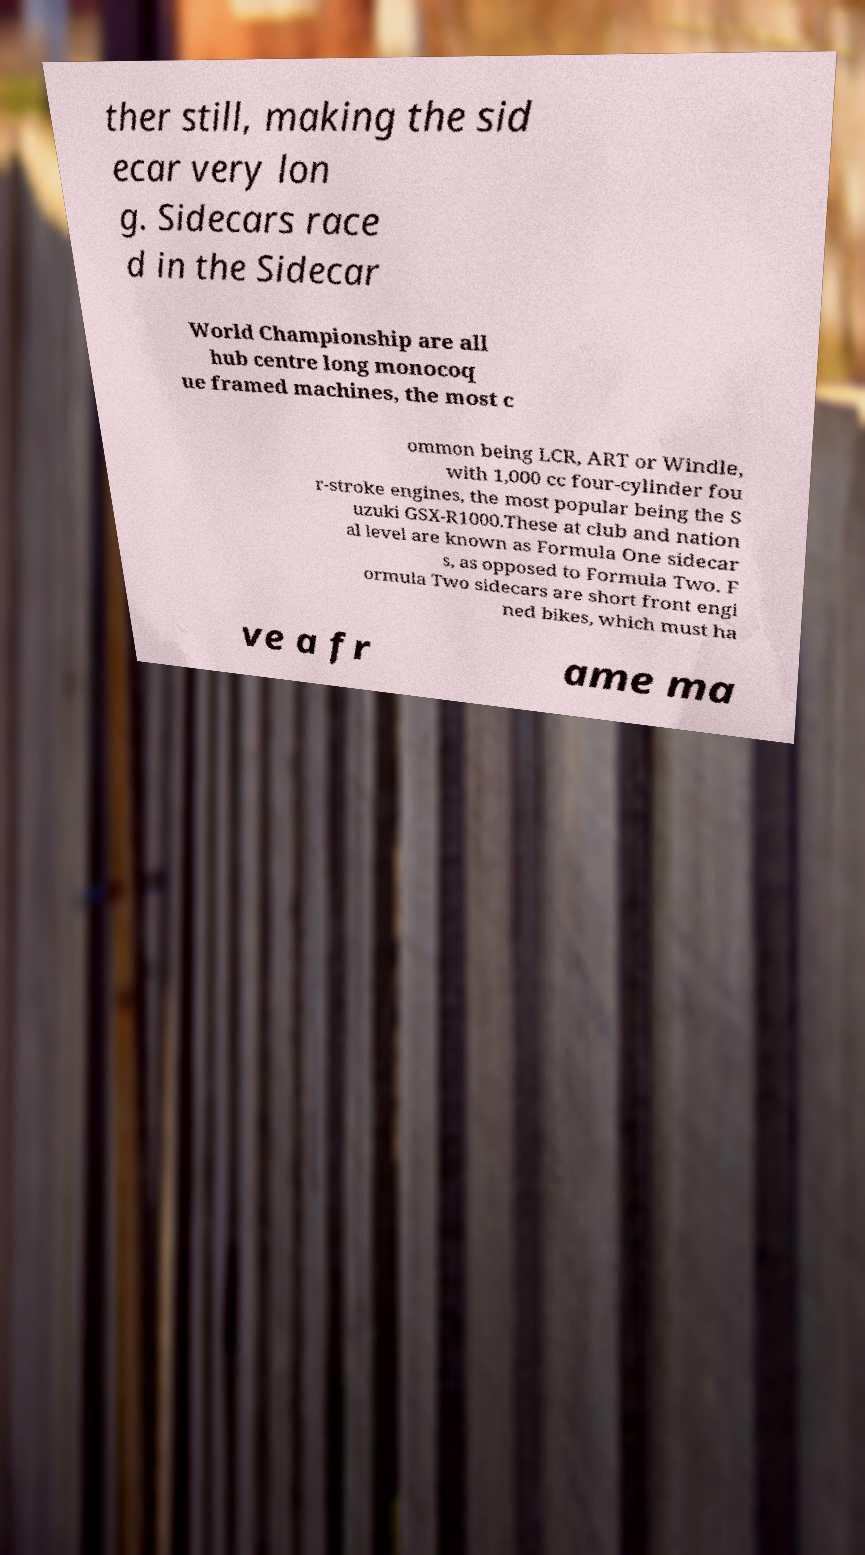What messages or text are displayed in this image? I need them in a readable, typed format. ther still, making the sid ecar very lon g. Sidecars race d in the Sidecar World Championship are all hub centre long monocoq ue framed machines, the most c ommon being LCR, ART or Windle, with 1,000 cc four-cylinder fou r-stroke engines, the most popular being the S uzuki GSX-R1000.These at club and nation al level are known as Formula One sidecar s, as opposed to Formula Two. F ormula Two sidecars are short front engi ned bikes, which must ha ve a fr ame ma 